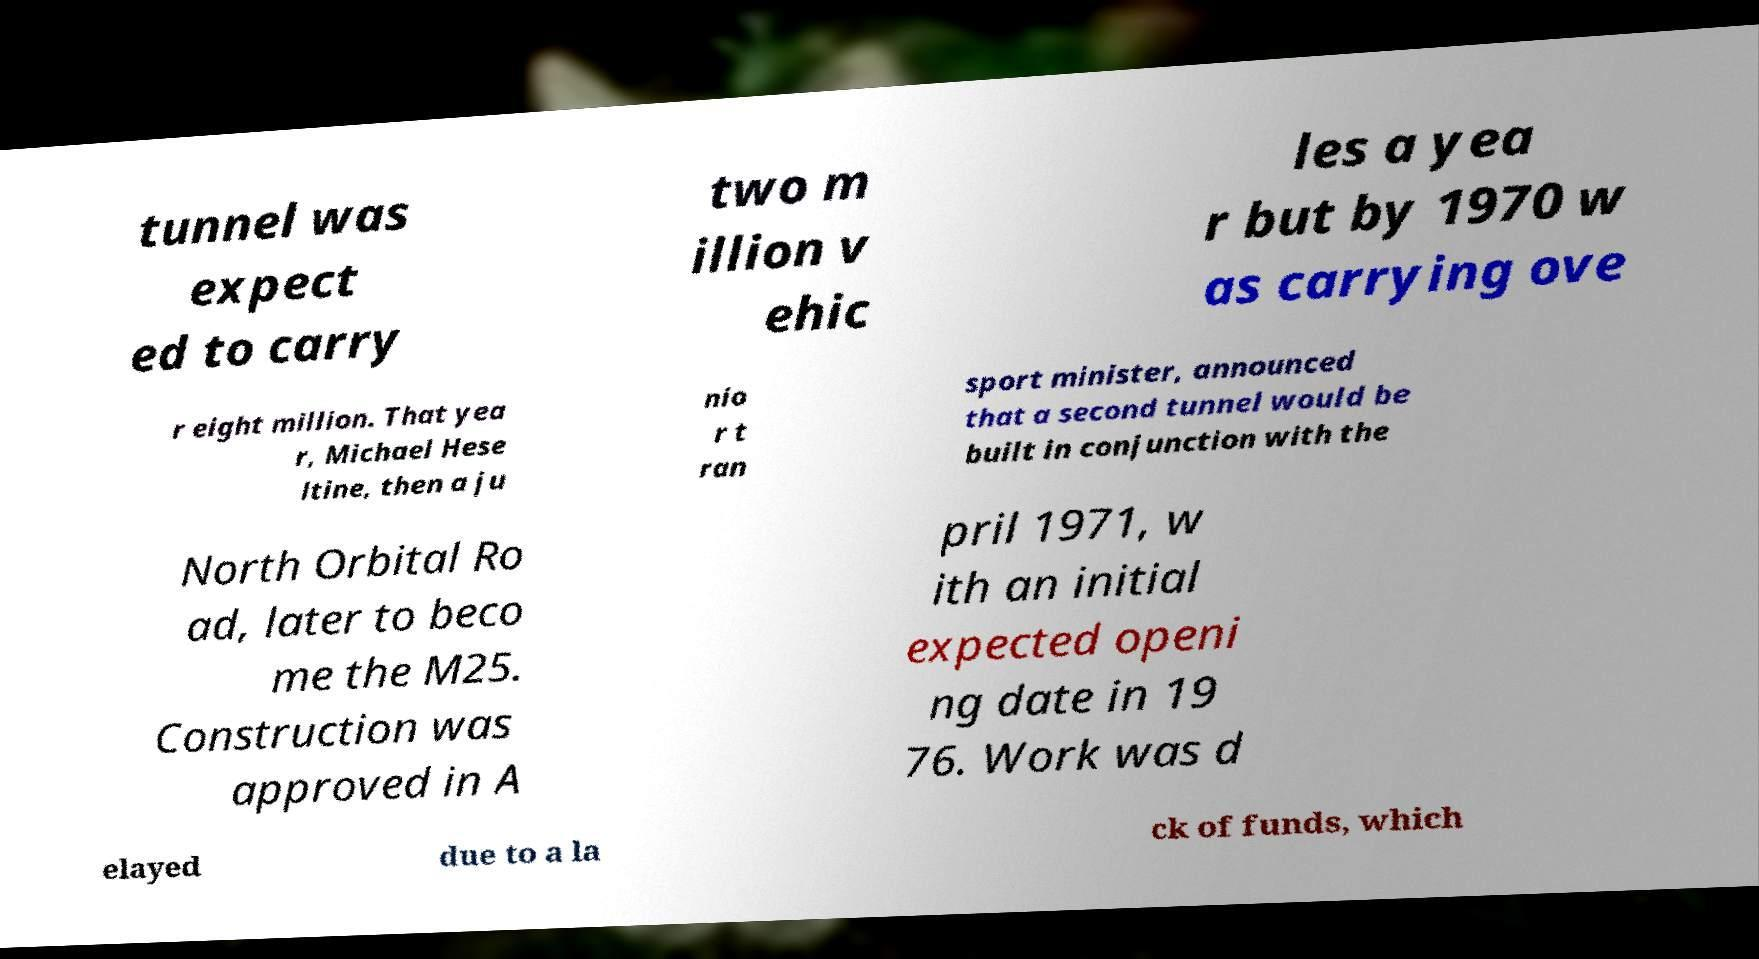There's text embedded in this image that I need extracted. Can you transcribe it verbatim? tunnel was expect ed to carry two m illion v ehic les a yea r but by 1970 w as carrying ove r eight million. That yea r, Michael Hese ltine, then a ju nio r t ran sport minister, announced that a second tunnel would be built in conjunction with the North Orbital Ro ad, later to beco me the M25. Construction was approved in A pril 1971, w ith an initial expected openi ng date in 19 76. Work was d elayed due to a la ck of funds, which 